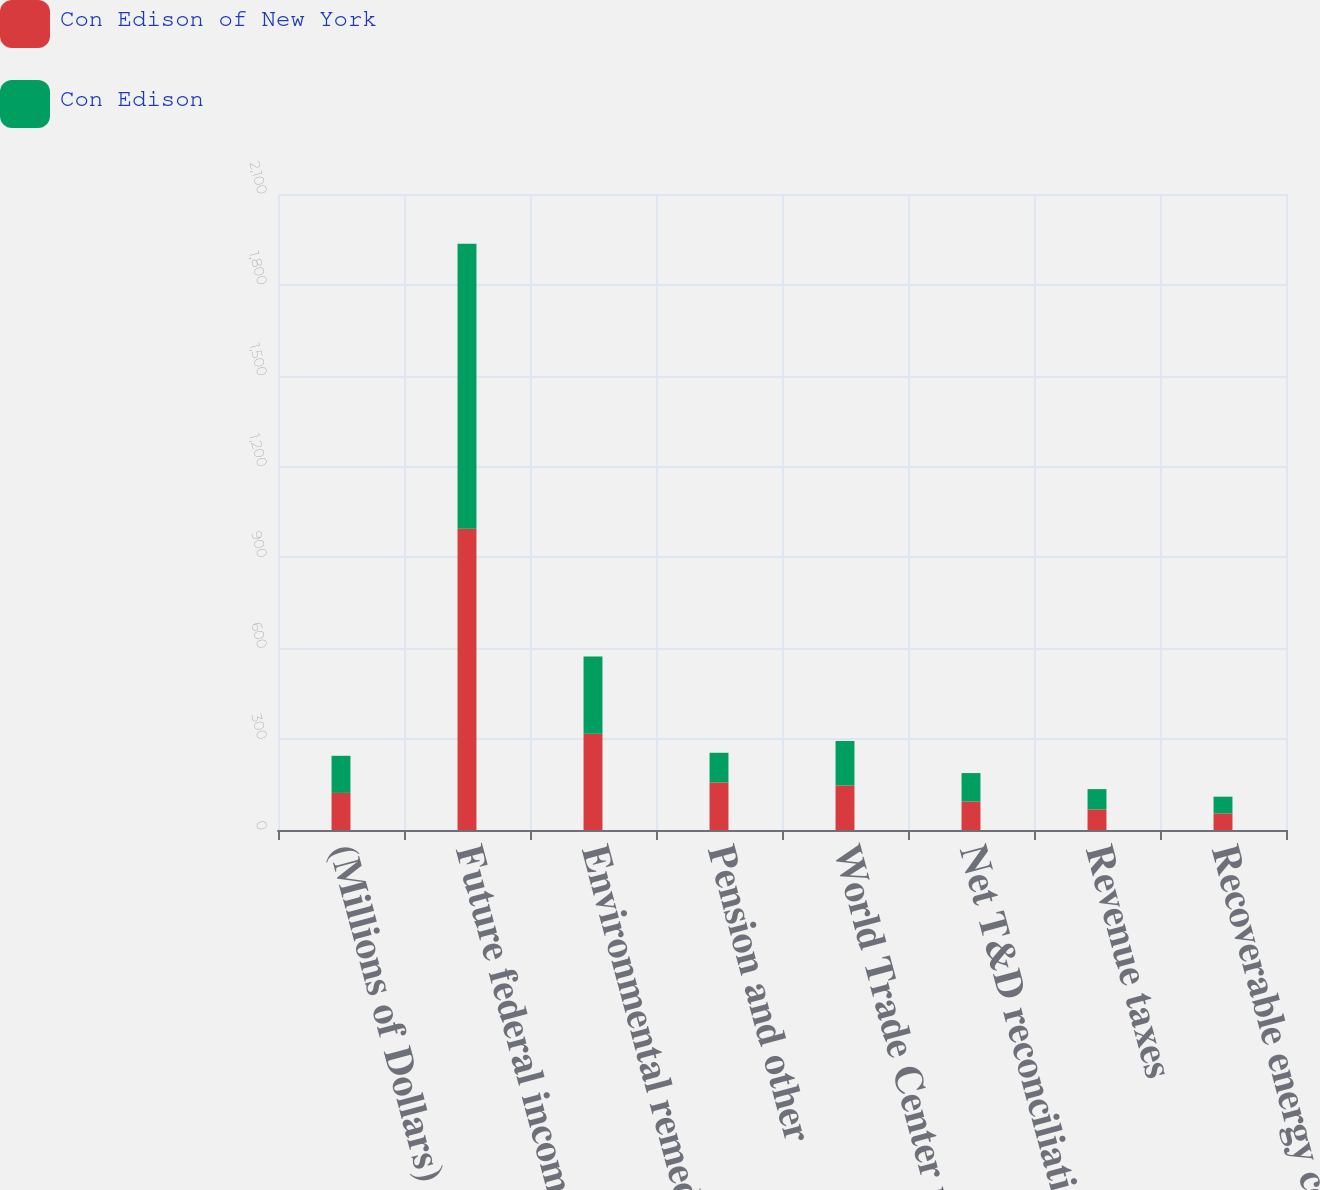Convert chart to OTSL. <chart><loc_0><loc_0><loc_500><loc_500><stacked_bar_chart><ecel><fcel>(Millions of Dollars)<fcel>Future federal income tax<fcel>Environmental remediation<fcel>Pension and other<fcel>World Trade Center restoration<fcel>Net T&D reconciliation<fcel>Revenue taxes<fcel>Recoverable energy costs<nl><fcel>Con Edison of New York<fcel>122.5<fcel>995<fcel>318<fcel>157<fcel>147<fcel>94<fcel>68<fcel>55<nl><fcel>Con Edison<fcel>122.5<fcel>941<fcel>255<fcel>98<fcel>147<fcel>94<fcel>67<fcel>55<nl></chart> 